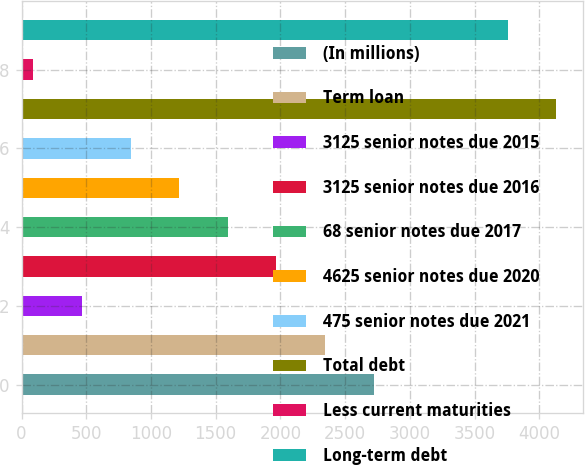<chart> <loc_0><loc_0><loc_500><loc_500><bar_chart><fcel>(In millions)<fcel>Term loan<fcel>3125 senior notes due 2015<fcel>3125 senior notes due 2016<fcel>68 senior notes due 2017<fcel>4625 senior notes due 2020<fcel>475 senior notes due 2021<fcel>Total debt<fcel>Less current maturities<fcel>Long-term debt<nl><fcel>2721.2<fcel>2345.6<fcel>467.6<fcel>1970<fcel>1594.4<fcel>1218.8<fcel>843.2<fcel>4131.6<fcel>92<fcel>3756<nl></chart> 